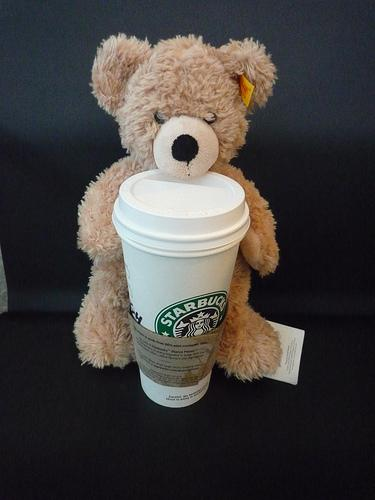Question: where is the bear?
Choices:
A. On a chair.
B. In a forest.
C. By a river.
D. Under a bush.
Answer with the letter. Answer: A Question: who is holding the cup?
Choices:
A. A woman.
B. Bear.
C. The bartender.
D. The todler.
Answer with the letter. Answer: B Question: what is the bear holding?
Choices:
A. A fish.
B. Coffee.
C. Ice.
D. A stick.
Answer with the letter. Answer: B Question: where is the cup?
Choices:
A. On a table.
B. In my hand.
C. The bear has it.
D. On the floor.
Answer with the letter. Answer: C 